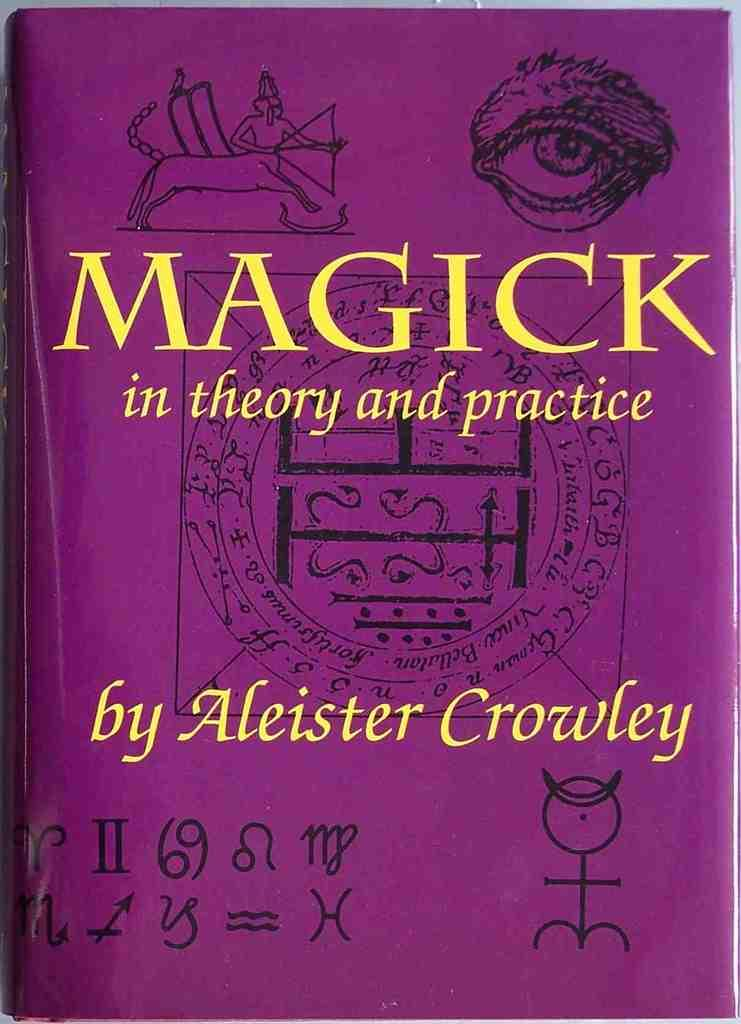<image>
Relay a brief, clear account of the picture shown. a book titled magick in theory and practice 